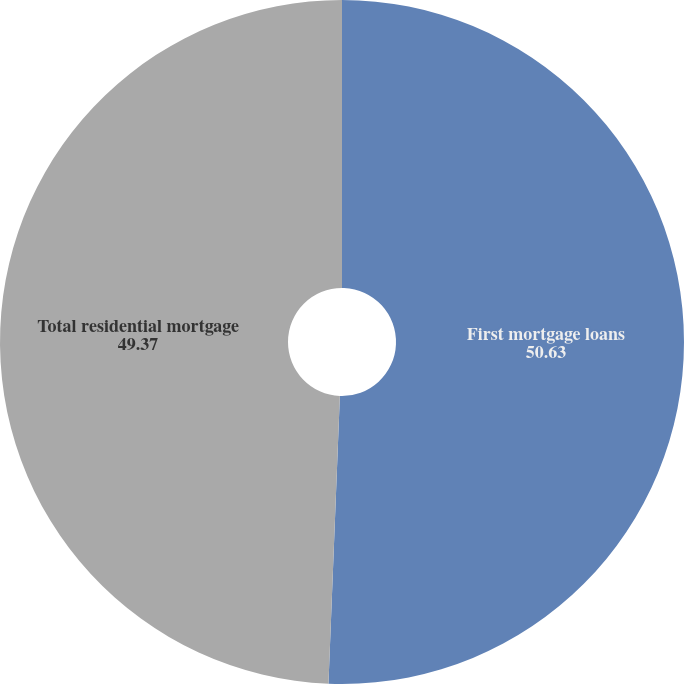Convert chart to OTSL. <chart><loc_0><loc_0><loc_500><loc_500><pie_chart><fcel>First mortgage loans<fcel>Total residential mortgage<nl><fcel>50.63%<fcel>49.37%<nl></chart> 